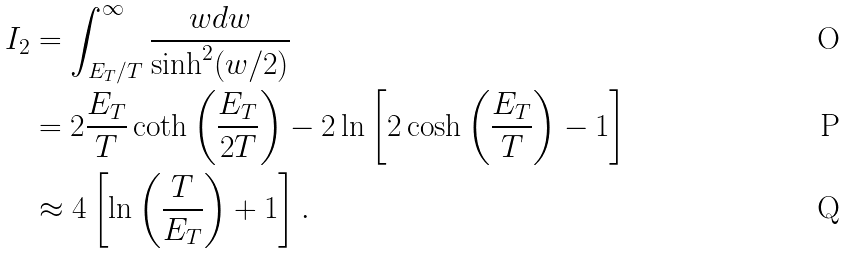<formula> <loc_0><loc_0><loc_500><loc_500>I _ { 2 } & = \int _ { E _ { T } / T } ^ { \infty } \frac { w d w } { \sinh ^ { 2 } ( w / 2 ) } \\ & = 2 \frac { E _ { T } } { T } \coth \left ( \frac { E _ { T } } { 2 T } \right ) - 2 \ln \left [ 2 \cosh \left ( \frac { E _ { T } } { T } \right ) - 1 \right ] \\ & \approx 4 \left [ \ln \left ( \frac { T } { E _ { T } } \right ) + 1 \right ] .</formula> 